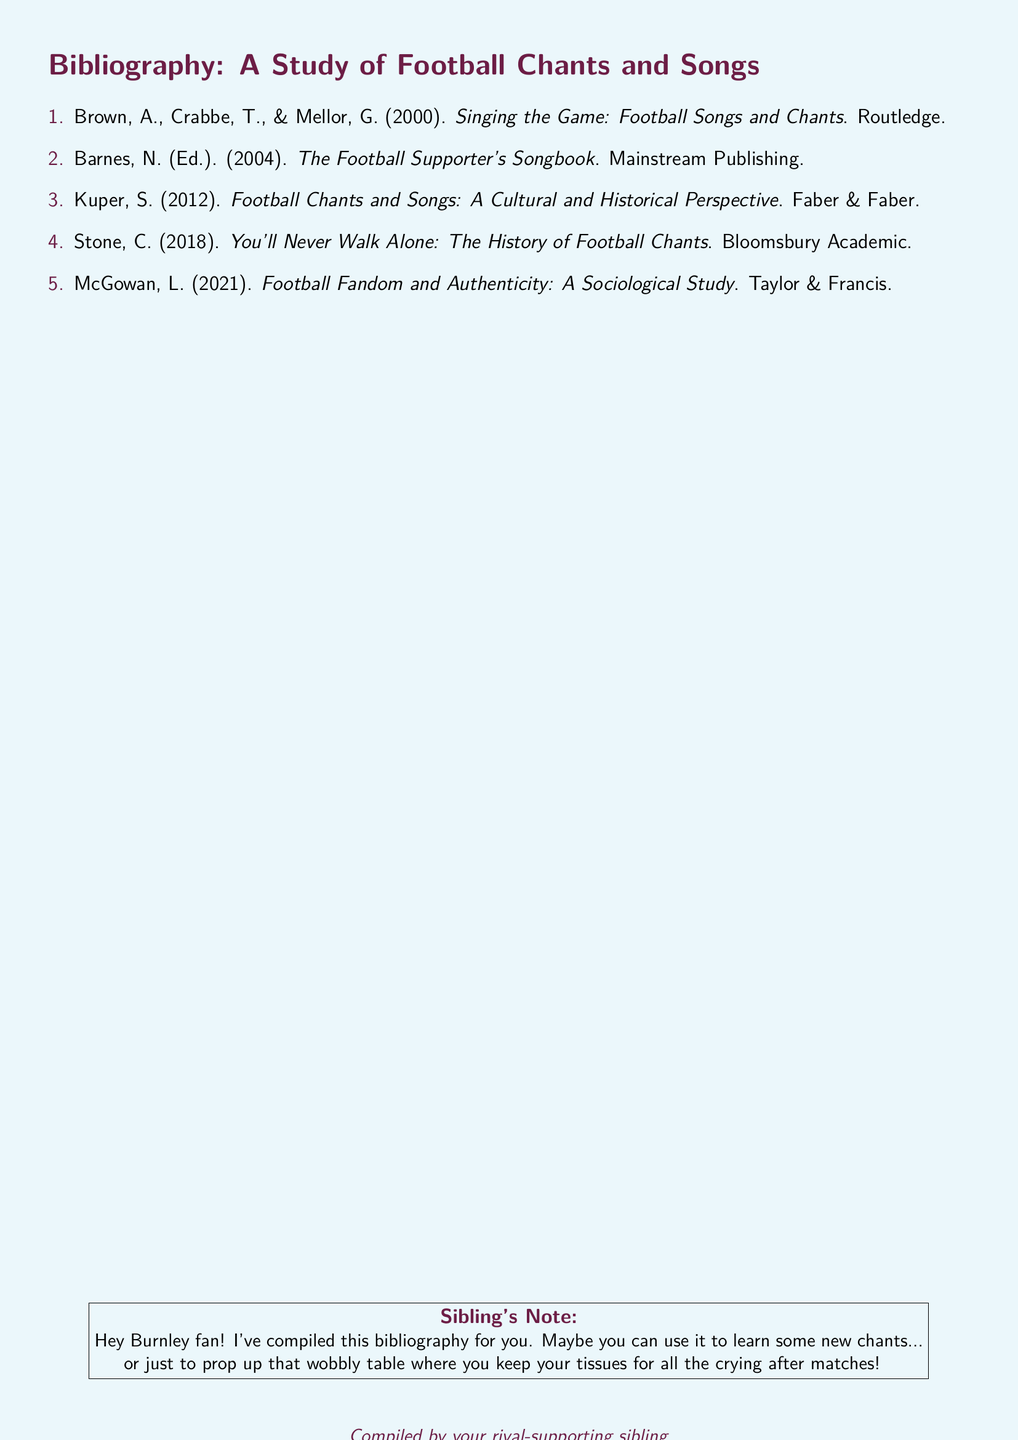what is the title of the first book listed? The title is given in the first entry of the bibliography, which is "Singing the Game: Football Songs and Chants".
Answer: Singing the Game: Football Songs and Chants who is the editor of the second book? The second entry mentions that N. Barnes is the editor of the book titled "The Football Supporter's Songbook".
Answer: N. Barnes which publishing company released the book authored by Kuper? The publishing company for the book "Football Chants and Songs: A Cultural and Historical Perspective" is Faber & Faber, as mentioned in its entry.
Answer: Faber & Faber how many total books are listed in the bibliography? The total number of books in the bibliography can be counted in the document, which lists five entries.
Answer: 5 what year was the book by McGowan published? The entry for McGowan's book provides the publication year as 2021.
Answer: 2021 what is the main theme of the bibliography? The bibliography focuses on football chants and songs, their history, and cultural significance, as inferred from the title.
Answer: Football chants and songs who is the author of the book that discusses the history of football chants? The bibliography provides that the author of "You'll Never Walk Alone: The History of Football Chants" is C. Stone.
Answer: C. Stone which color is used for the document's page background? The document states the color for the page background as a light shade of blue, referred to as burnleysky.
Answer: burnleysky 